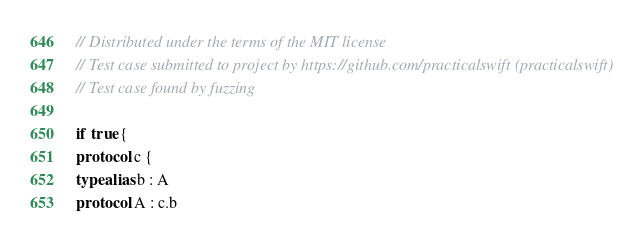<code> <loc_0><loc_0><loc_500><loc_500><_Swift_>// Distributed under the terms of the MIT license
// Test case submitted to project by https://github.com/practicalswift (practicalswift)
// Test case found by fuzzing

if true {
protocol c {
typealias b : A
protocol A : c.b
</code> 